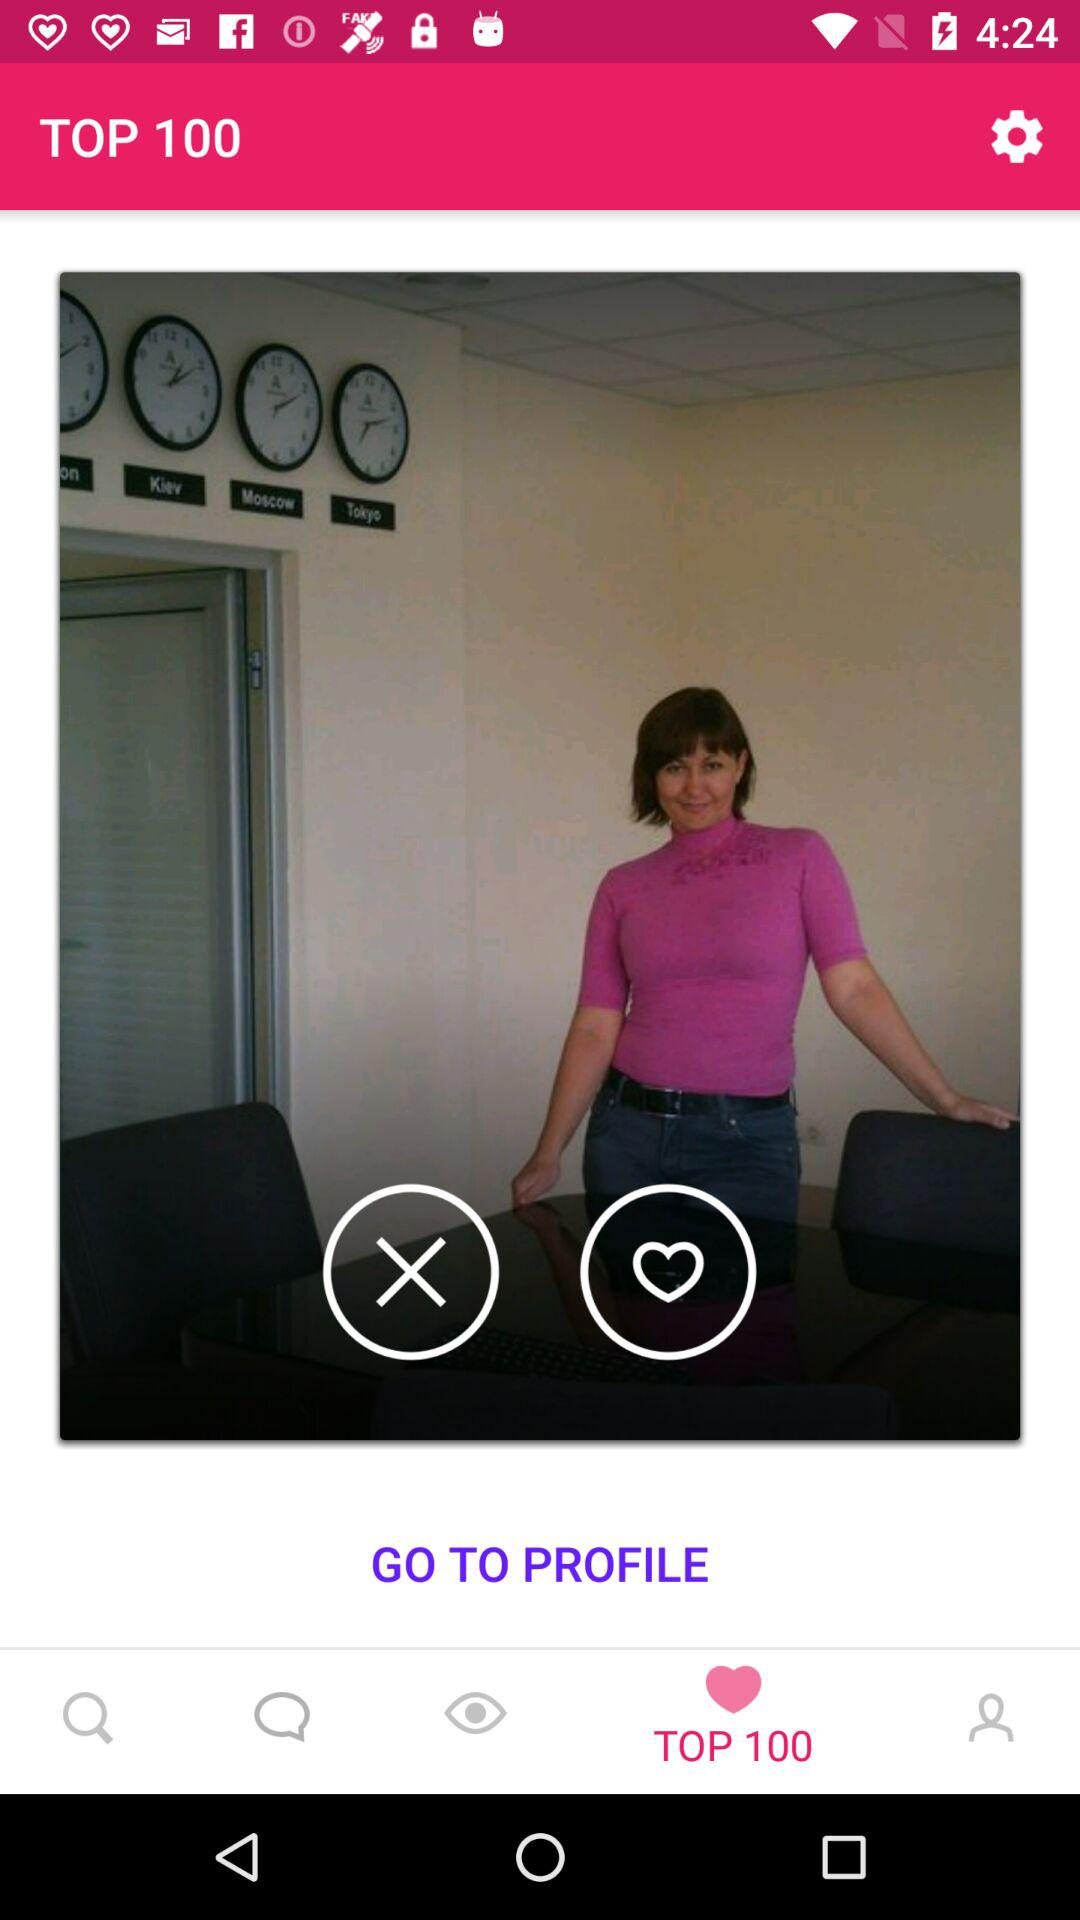What is the application name?
When the provided information is insufficient, respond with <no answer>. <no answer> 